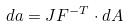<formula> <loc_0><loc_0><loc_500><loc_500>d a = J F ^ { - T } \cdot d A</formula> 